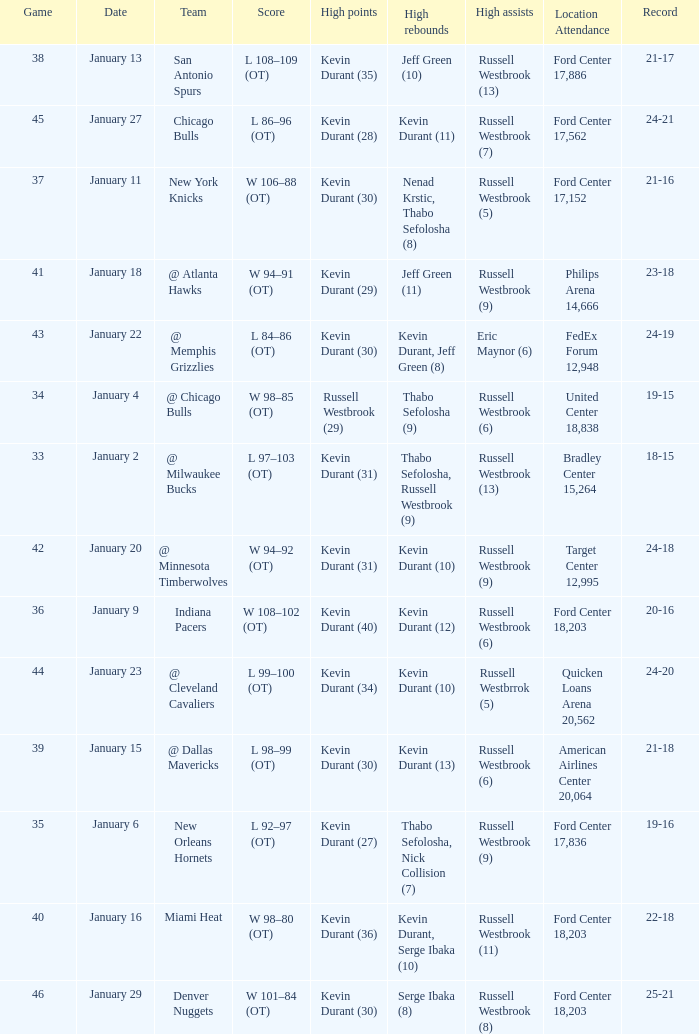Name the team for january 4 @ Chicago Bulls. 